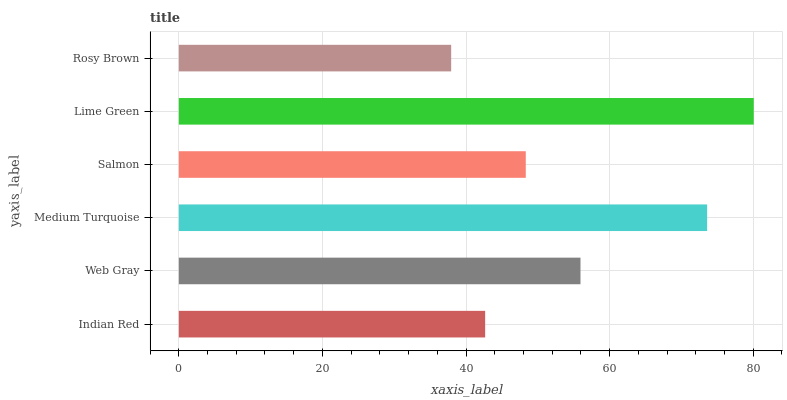Is Rosy Brown the minimum?
Answer yes or no. Yes. Is Lime Green the maximum?
Answer yes or no. Yes. Is Web Gray the minimum?
Answer yes or no. No. Is Web Gray the maximum?
Answer yes or no. No. Is Web Gray greater than Indian Red?
Answer yes or no. Yes. Is Indian Red less than Web Gray?
Answer yes or no. Yes. Is Indian Red greater than Web Gray?
Answer yes or no. No. Is Web Gray less than Indian Red?
Answer yes or no. No. Is Web Gray the high median?
Answer yes or no. Yes. Is Salmon the low median?
Answer yes or no. Yes. Is Lime Green the high median?
Answer yes or no. No. Is Rosy Brown the low median?
Answer yes or no. No. 